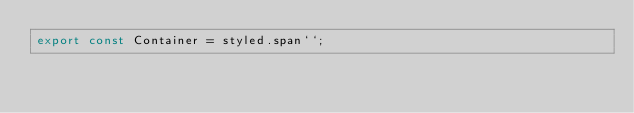<code> <loc_0><loc_0><loc_500><loc_500><_TypeScript_>export const Container = styled.span``;
</code> 